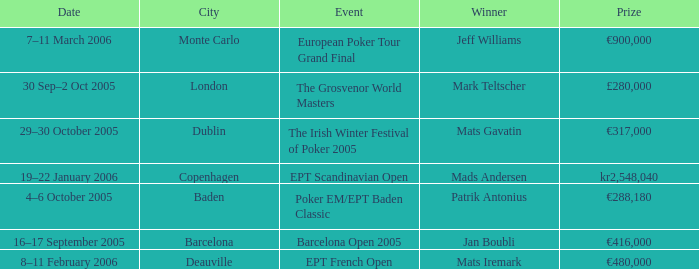What event had a prize of €900,000? European Poker Tour Grand Final. 